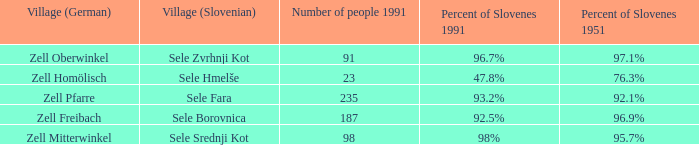Provide me with the name of the village (German) where there is 96.9% Slovenes in 1951.  Zell Freibach. 